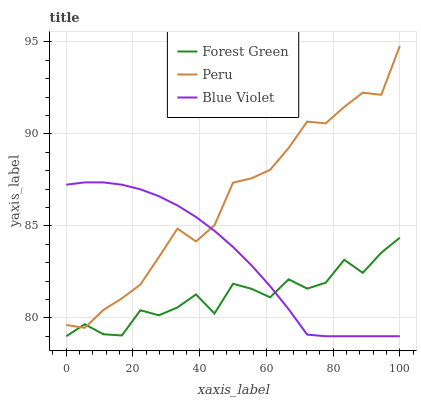Does Forest Green have the minimum area under the curve?
Answer yes or no. Yes. Does Peru have the maximum area under the curve?
Answer yes or no. Yes. Does Blue Violet have the minimum area under the curve?
Answer yes or no. No. Does Blue Violet have the maximum area under the curve?
Answer yes or no. No. Is Blue Violet the smoothest?
Answer yes or no. Yes. Is Forest Green the roughest?
Answer yes or no. Yes. Is Peru the smoothest?
Answer yes or no. No. Is Peru the roughest?
Answer yes or no. No. Does Forest Green have the lowest value?
Answer yes or no. Yes. Does Peru have the lowest value?
Answer yes or no. No. Does Peru have the highest value?
Answer yes or no. Yes. Does Blue Violet have the highest value?
Answer yes or no. No. Does Forest Green intersect Blue Violet?
Answer yes or no. Yes. Is Forest Green less than Blue Violet?
Answer yes or no. No. Is Forest Green greater than Blue Violet?
Answer yes or no. No. 